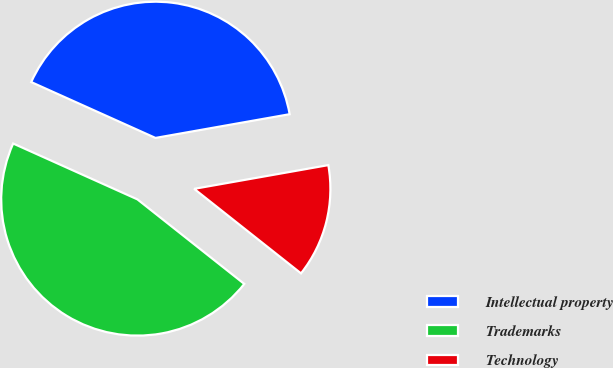Convert chart to OTSL. <chart><loc_0><loc_0><loc_500><loc_500><pie_chart><fcel>Intellectual property<fcel>Trademarks<fcel>Technology<nl><fcel>40.49%<fcel>46.07%<fcel>13.44%<nl></chart> 